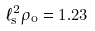Convert formula to latex. <formula><loc_0><loc_0><loc_500><loc_500>\ell _ { s } ^ { 2 } \rho _ { o } = 1 . 2 3</formula> 